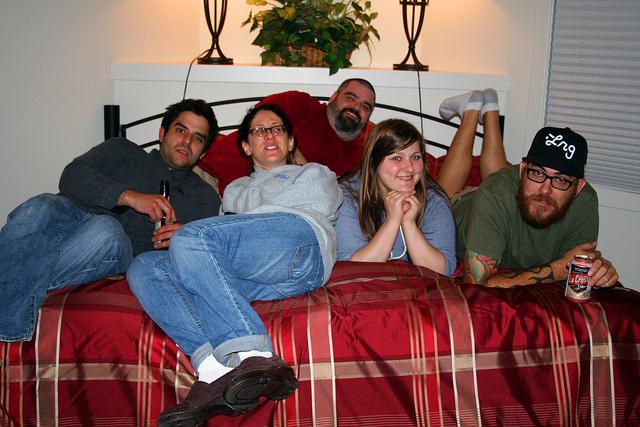What is the design of the bedspread?
Give a very brief answer. Plaid. How many people are on the bed?
Be succinct. 5. Does the bed have side tables?
Keep it brief. No. Is there a kid in the bed?
Be succinct. No. How many feet can you see in this picture?
Quick response, please. 4. 